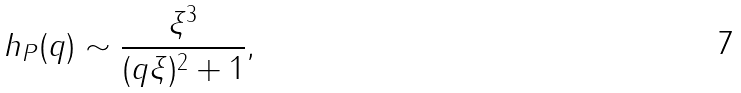<formula> <loc_0><loc_0><loc_500><loc_500>h _ { P } ( q ) \sim \frac { \xi ^ { 3 } } { ( q \xi ) ^ { 2 } + 1 } ,</formula> 